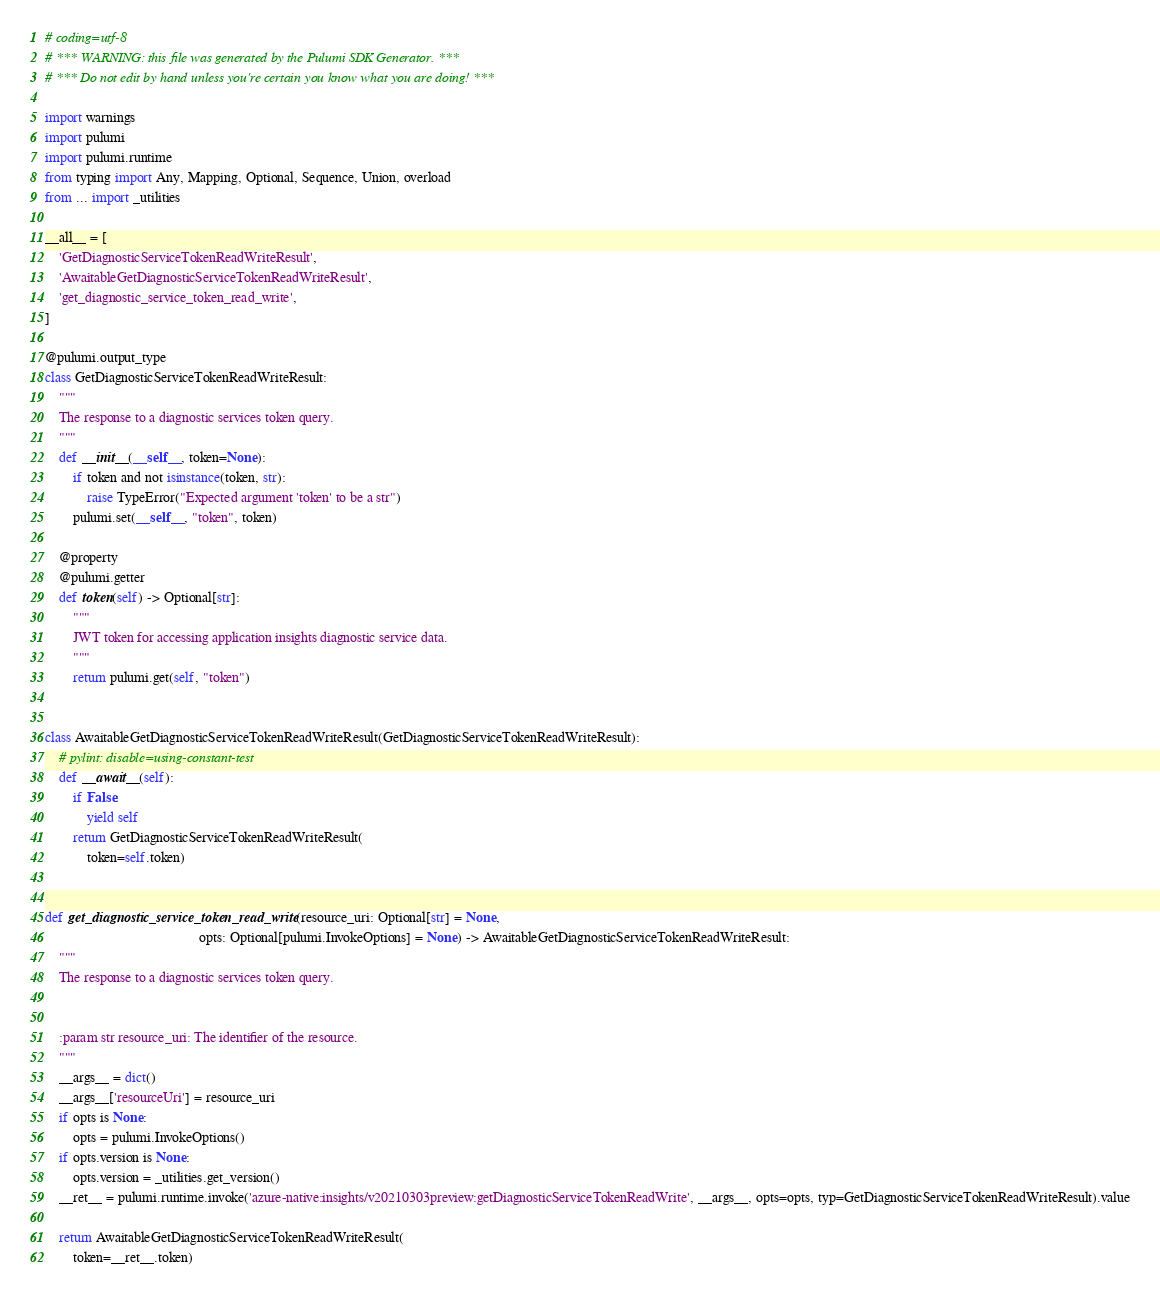Convert code to text. <code><loc_0><loc_0><loc_500><loc_500><_Python_># coding=utf-8
# *** WARNING: this file was generated by the Pulumi SDK Generator. ***
# *** Do not edit by hand unless you're certain you know what you are doing! ***

import warnings
import pulumi
import pulumi.runtime
from typing import Any, Mapping, Optional, Sequence, Union, overload
from ... import _utilities

__all__ = [
    'GetDiagnosticServiceTokenReadWriteResult',
    'AwaitableGetDiagnosticServiceTokenReadWriteResult',
    'get_diagnostic_service_token_read_write',
]

@pulumi.output_type
class GetDiagnosticServiceTokenReadWriteResult:
    """
    The response to a diagnostic services token query.
    """
    def __init__(__self__, token=None):
        if token and not isinstance(token, str):
            raise TypeError("Expected argument 'token' to be a str")
        pulumi.set(__self__, "token", token)

    @property
    @pulumi.getter
    def token(self) -> Optional[str]:
        """
        JWT token for accessing application insights diagnostic service data.
        """
        return pulumi.get(self, "token")


class AwaitableGetDiagnosticServiceTokenReadWriteResult(GetDiagnosticServiceTokenReadWriteResult):
    # pylint: disable=using-constant-test
    def __await__(self):
        if False:
            yield self
        return GetDiagnosticServiceTokenReadWriteResult(
            token=self.token)


def get_diagnostic_service_token_read_write(resource_uri: Optional[str] = None,
                                            opts: Optional[pulumi.InvokeOptions] = None) -> AwaitableGetDiagnosticServiceTokenReadWriteResult:
    """
    The response to a diagnostic services token query.


    :param str resource_uri: The identifier of the resource.
    """
    __args__ = dict()
    __args__['resourceUri'] = resource_uri
    if opts is None:
        opts = pulumi.InvokeOptions()
    if opts.version is None:
        opts.version = _utilities.get_version()
    __ret__ = pulumi.runtime.invoke('azure-native:insights/v20210303preview:getDiagnosticServiceTokenReadWrite', __args__, opts=opts, typ=GetDiagnosticServiceTokenReadWriteResult).value

    return AwaitableGetDiagnosticServiceTokenReadWriteResult(
        token=__ret__.token)
</code> 